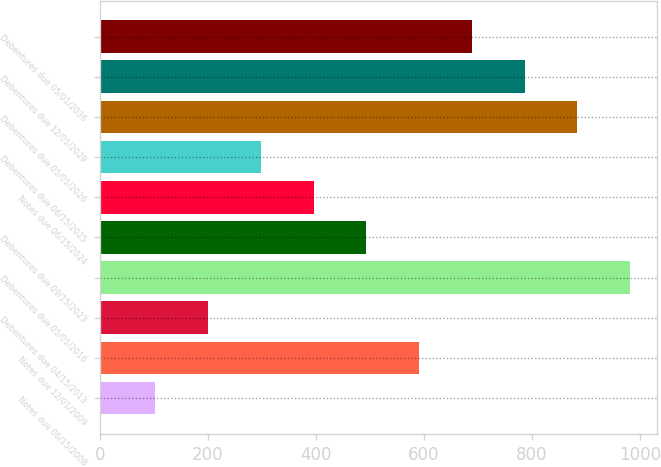Convert chart. <chart><loc_0><loc_0><loc_500><loc_500><bar_chart><fcel>Notes due 06/15/2008<fcel>Notes due 12/01/2009<fcel>Debentures due 04/15/2013<fcel>Debentures due 05/01/2016<fcel>Debentures due 09/15/2023<fcel>Notes due 06/15/2024<fcel>Debentures due 06/15/2025<fcel>Debentures due 05/01/2026<fcel>Debentures due 12/01/2029<fcel>Debentures due 05/01/2036<nl><fcel>103<fcel>591<fcel>200.6<fcel>981.4<fcel>493.4<fcel>395.8<fcel>298.2<fcel>883.8<fcel>786.2<fcel>688.6<nl></chart> 